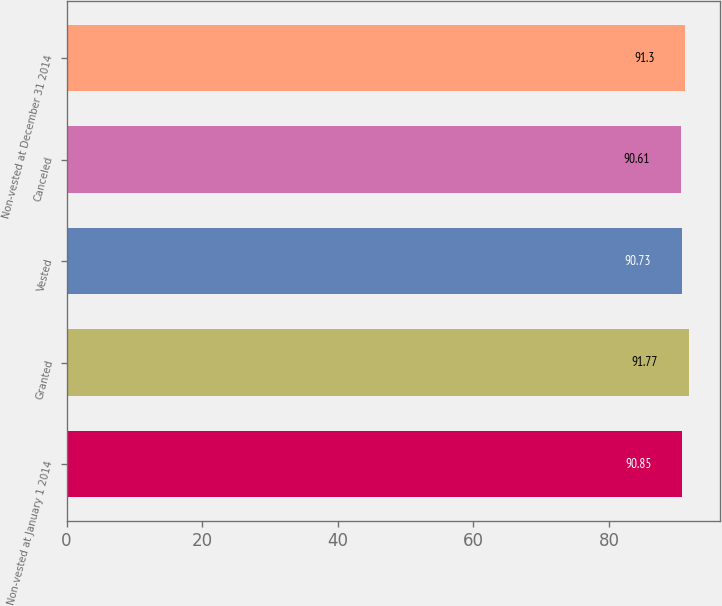<chart> <loc_0><loc_0><loc_500><loc_500><bar_chart><fcel>Non-vested at January 1 2014<fcel>Granted<fcel>Vested<fcel>Canceled<fcel>Non-vested at December 31 2014<nl><fcel>90.85<fcel>91.77<fcel>90.73<fcel>90.61<fcel>91.3<nl></chart> 